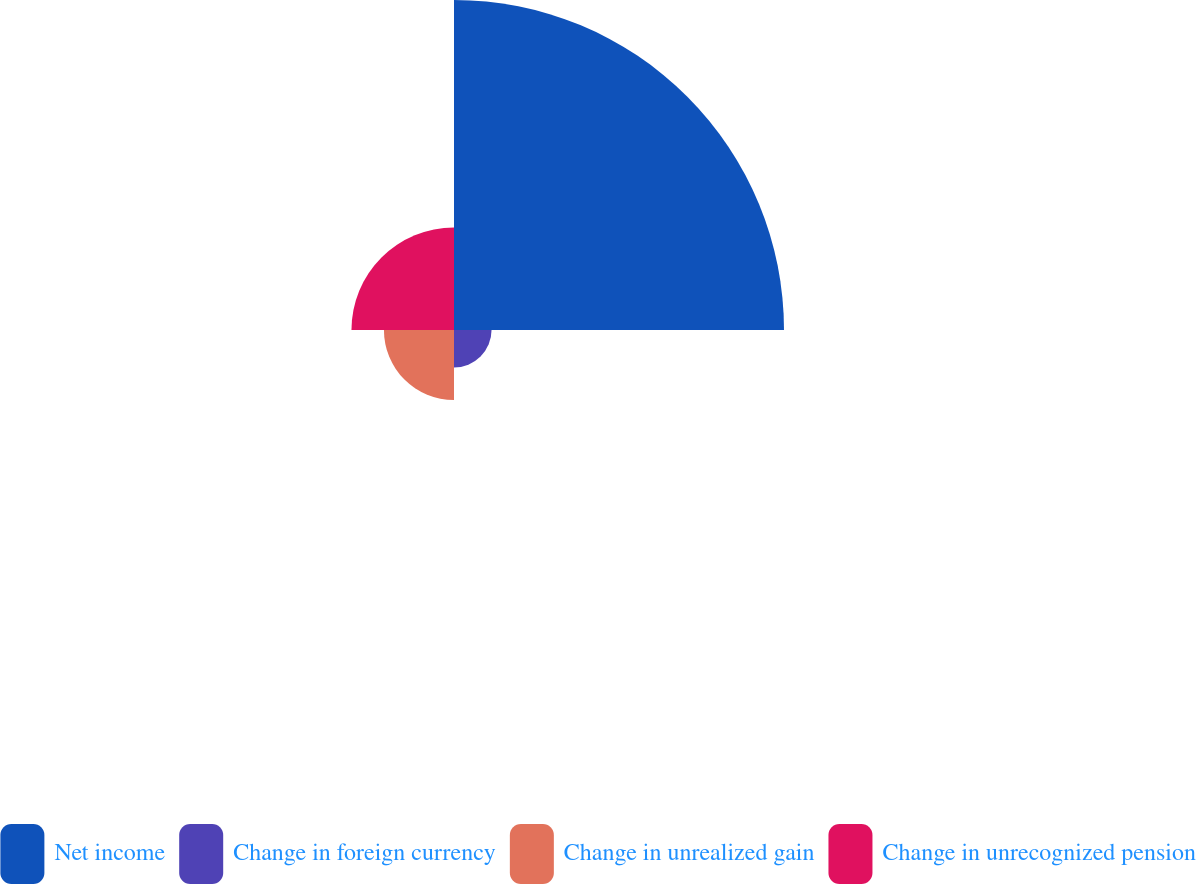<chart> <loc_0><loc_0><loc_500><loc_500><pie_chart><fcel>Net income<fcel>Change in foreign currency<fcel>Change in unrealized gain<fcel>Change in unrecognized pension<nl><fcel>61.09%<fcel>6.95%<fcel>12.97%<fcel>18.98%<nl></chart> 